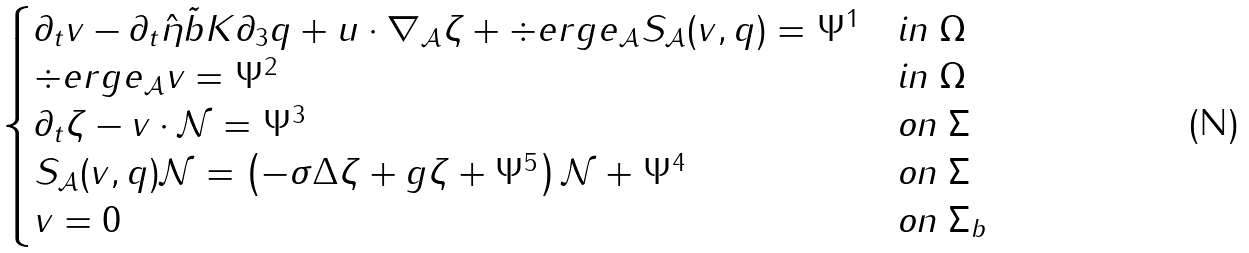Convert formula to latex. <formula><loc_0><loc_0><loc_500><loc_500>\begin{cases} \partial _ { t } v - \partial _ { t } \hat { \eta } \tilde { b } K \partial _ { 3 } q + u \cdot \nabla _ { \mathcal { A } } \zeta + \div e r g e _ { \mathcal { A } } S _ { \mathcal { A } } ( v , q ) = \Psi ^ { 1 } & \text {in $\Omega$} \\ \div e r g e _ { \mathcal { A } } v = \Psi ^ { 2 } & \text {in $\Omega$} \\ \partial _ { t } \zeta - v \cdot \mathcal { N } = \Psi ^ { 3 } & \text {on $\Sigma$} \\ S _ { \mathcal { A } } ( v , q ) \mathcal { N } = \left ( - \sigma \Delta \zeta + g \zeta + \Psi ^ { 5 } \right ) \mathcal { N } + \Psi ^ { 4 } & \text {on $\Sigma$} \\ v = 0 & \text {on $\Sigma_{b}$} \end{cases}</formula> 